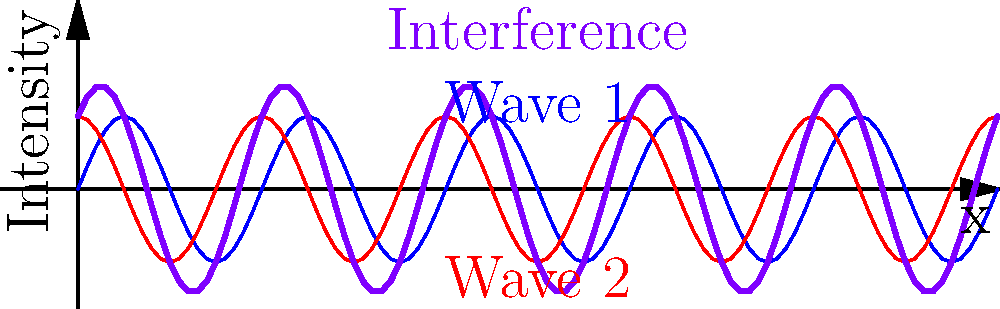In the context of the double-slit experiment, the graph shows two individual waves (blue and red) and their interference pattern (purple). How does this interference pattern relate to the societal implications of quantum mechanics, particularly in terms of determinism and free will? To answer this question, let's break it down step-by-step:

1. The double-slit experiment demonstrates the wave-particle duality of quantum mechanics. The interference pattern (purple line) is created by the superposition of two waves (blue and red lines).

2. In classical physics, particles follow deterministic paths. However, the double-slit experiment shows that quantum particles behave like waves and can interfere with themselves, creating an interference pattern.

3. This interference pattern is probabilistic in nature. We can predict where particles are more likely to land, but not the exact location of any individual particle.

4. The probabilistic nature of quantum mechanics challenges the classical notion of determinism, which suggests that all events are predetermined by prior causes.

5. This inherent uncertainty at the quantum level has led some philosophers and scientists to speculate about its implications for free will and consciousness.

6. The debate centers around whether quantum indeterminacy could provide a mechanism for free will, or if it simply introduces randomness without true choice.

7. From a sociological perspective, this impacts how we view human behavior and social systems. If quantum effects influence brain processes, it could challenge deterministic views of human action and social prediction.

8. However, it's important to note that the connection between quantum mechanics and free will is highly speculative and debated among experts.

9. The societal implications of this debate extend to areas such as ethics, law, and social policy, potentially influencing how we attribute responsibility for actions and design social interventions.

10. Understanding these concepts can also impact public perception of science and technology, potentially influencing support for research and technological development.
Answer: The interference pattern in the double-slit experiment challenges determinism, sparking debates about free will and social responsibility, which has wide-ranging societal implications. 